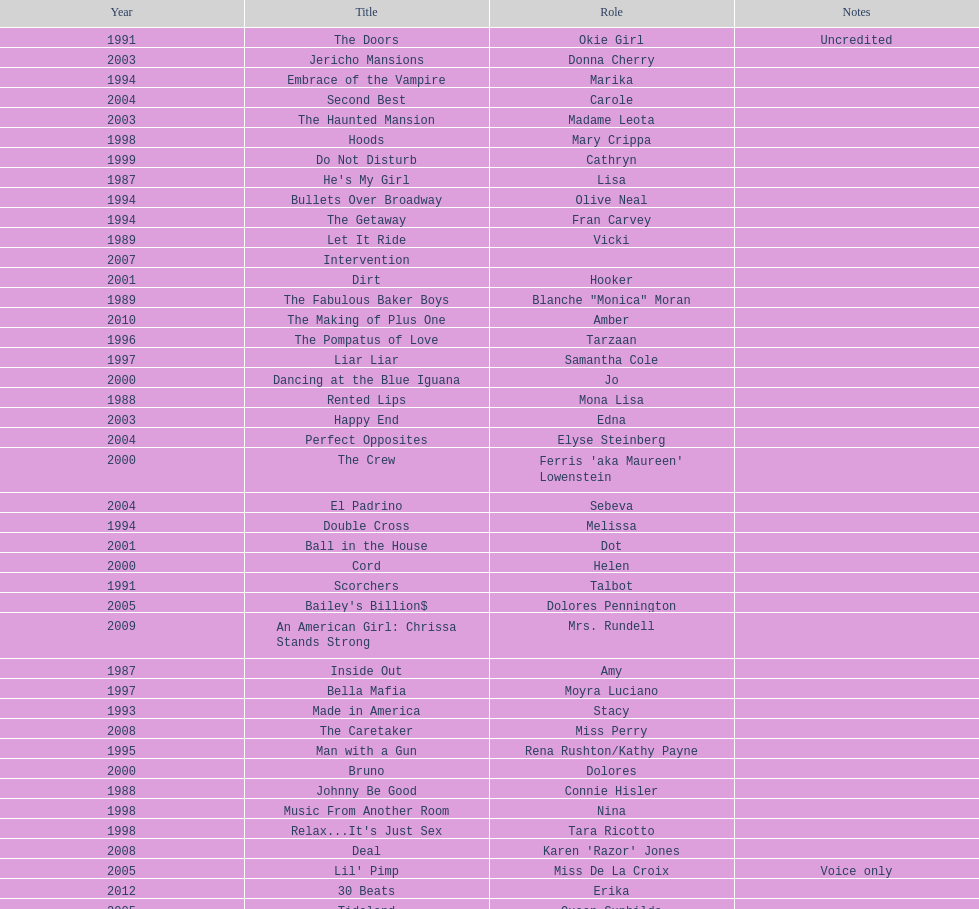Which film aired in 1994 and has marika as the role? Embrace of the Vampire. 